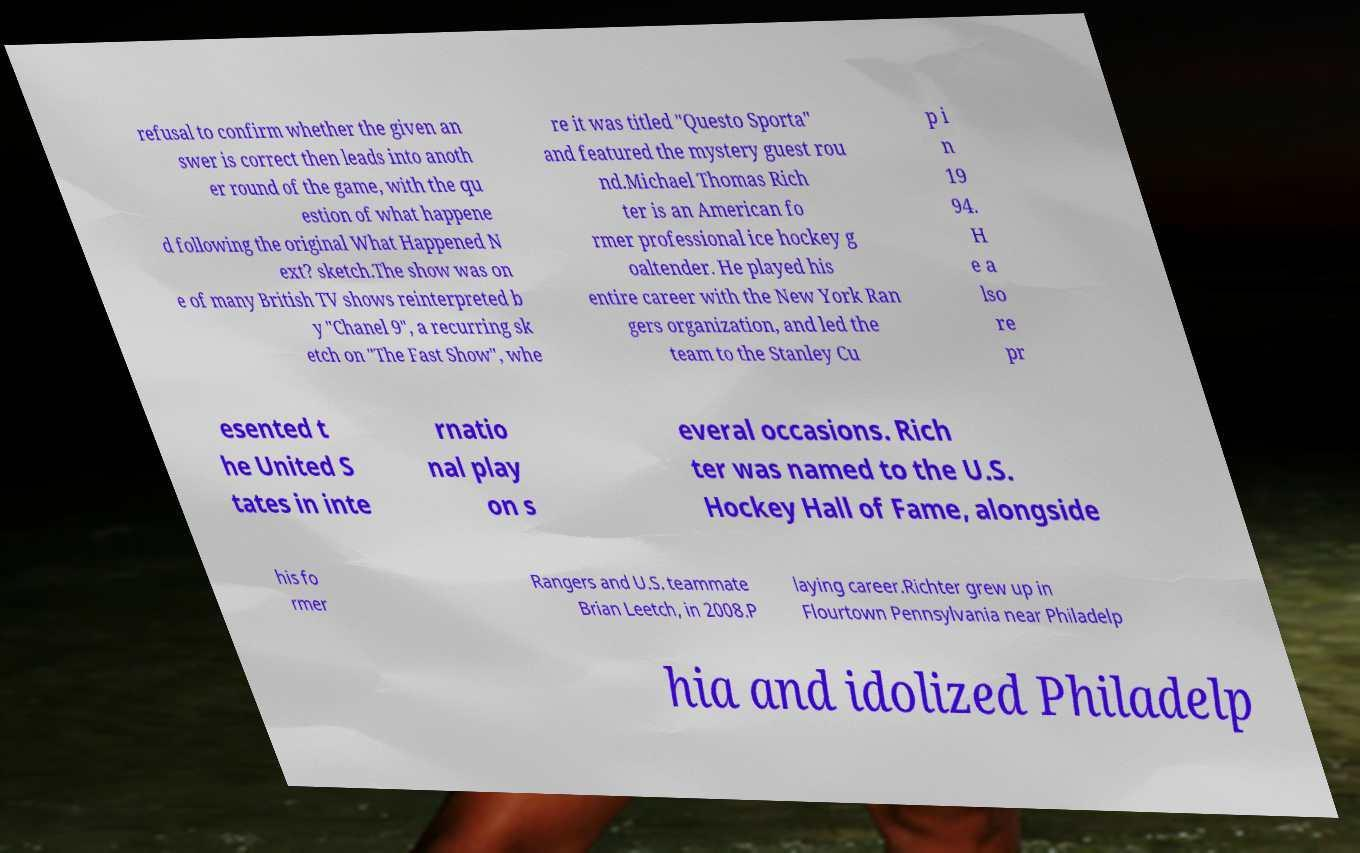Can you read and provide the text displayed in the image?This photo seems to have some interesting text. Can you extract and type it out for me? refusal to confirm whether the given an swer is correct then leads into anoth er round of the game, with the qu estion of what happene d following the original What Happened N ext? sketch.The show was on e of many British TV shows reinterpreted b y "Chanel 9", a recurring sk etch on "The Fast Show", whe re it was titled "Questo Sporta" and featured the mystery guest rou nd.Michael Thomas Rich ter is an American fo rmer professional ice hockey g oaltender. He played his entire career with the New York Ran gers organization, and led the team to the Stanley Cu p i n 19 94. H e a lso re pr esented t he United S tates in inte rnatio nal play on s everal occasions. Rich ter was named to the U.S. Hockey Hall of Fame, alongside his fo rmer Rangers and U.S. teammate Brian Leetch, in 2008.P laying career.Richter grew up in Flourtown Pennsylvania near Philadelp hia and idolized Philadelp 